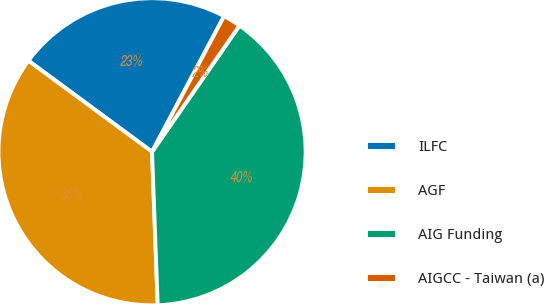Convert chart to OTSL. <chart><loc_0><loc_0><loc_500><loc_500><pie_chart><fcel>ILFC<fcel>AGF<fcel>AIG Funding<fcel>AIGCC - Taiwan (a)<nl><fcel>22.67%<fcel>35.69%<fcel>39.77%<fcel>1.87%<nl></chart> 